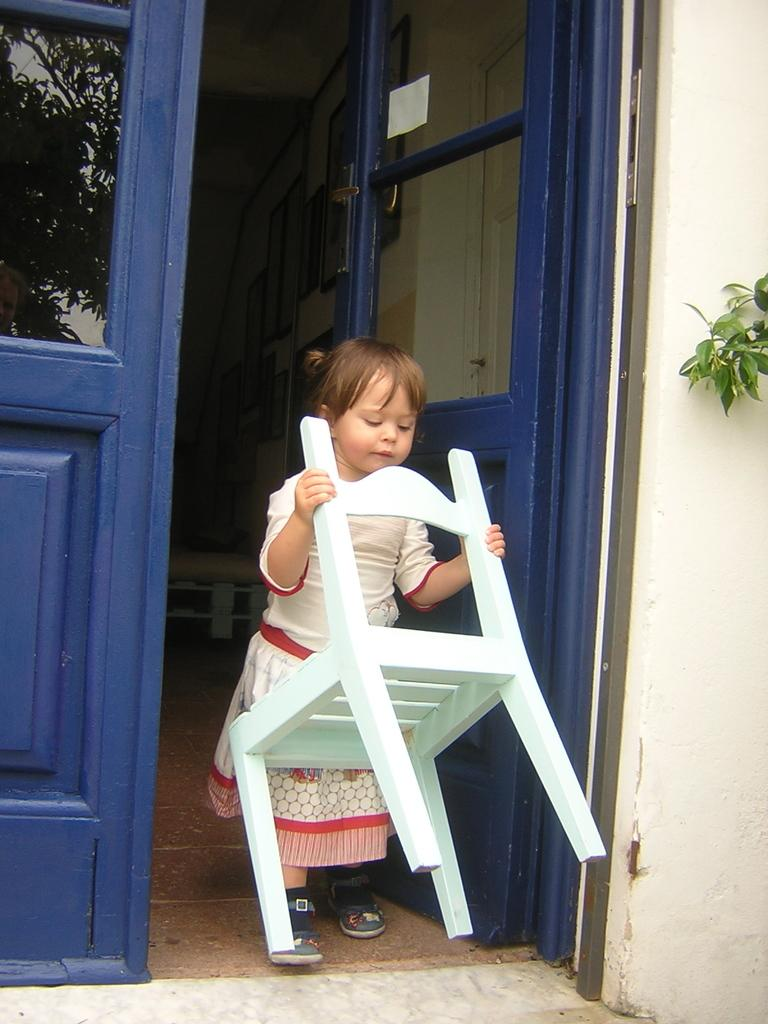Who is the main subject in the image? There is a small girl in the image. What is the girl doing in the image? The girl is holding a chair. What type of architectural features can be seen in the image? There are doors and a wall in the image. What natural element is partially visible in the image? A branch is partially visible in the image. What decorative items are present on the wall in the background? There are photo frames on the wall in the background. What type of trousers is the girl wearing in the image? The provided facts do not mention the girl's trousers, so we cannot determine the type of trousers she is wearing. What is the title of the image? The provided facts do not mention a title for the image. 